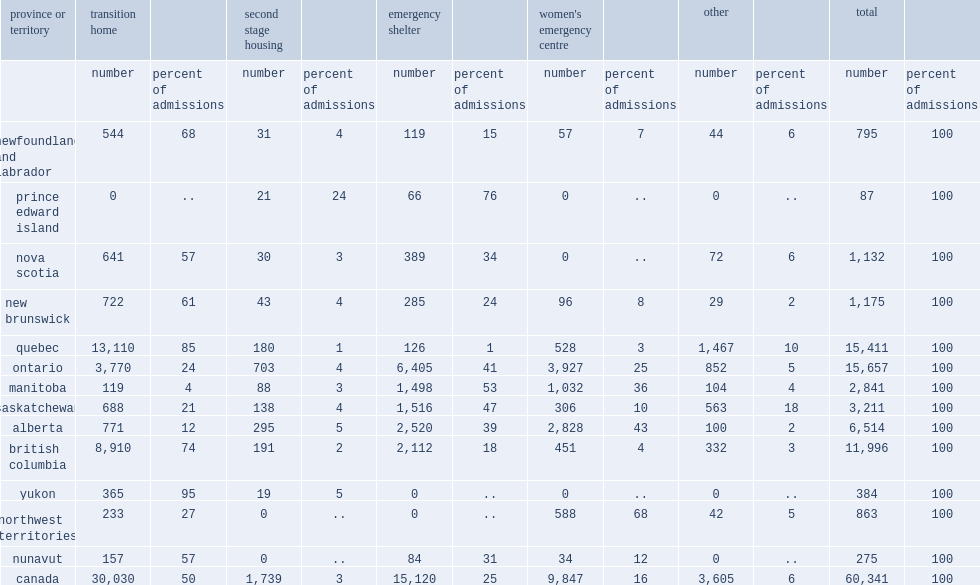Of the women admitted to shelter facilities in 2013/2014, how many percent of total admissions in canada were to transition homes? 50.0. How many percent of total admissions in canada were to emergency shelters and women's emergency centres? 41. How many percent of total admissions in canada were to second-stage housing. 3.0. How many of total admissions in canada were to other residential facilities. 6.0. 